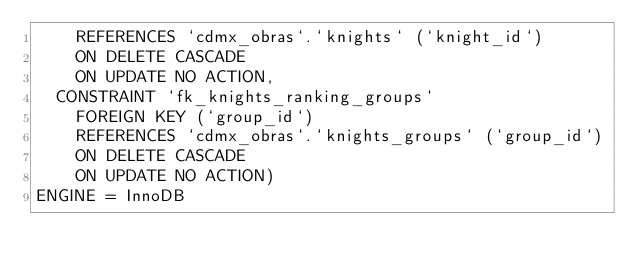Convert code to text. <code><loc_0><loc_0><loc_500><loc_500><_SQL_>    REFERENCES `cdmx_obras`.`knights` (`knight_id`)
    ON DELETE CASCADE
    ON UPDATE NO ACTION,
  CONSTRAINT `fk_knights_ranking_groups`
    FOREIGN KEY (`group_id`)
    REFERENCES `cdmx_obras`.`knights_groups` (`group_id`)
    ON DELETE CASCADE
    ON UPDATE NO ACTION)
ENGINE = InnoDB</code> 